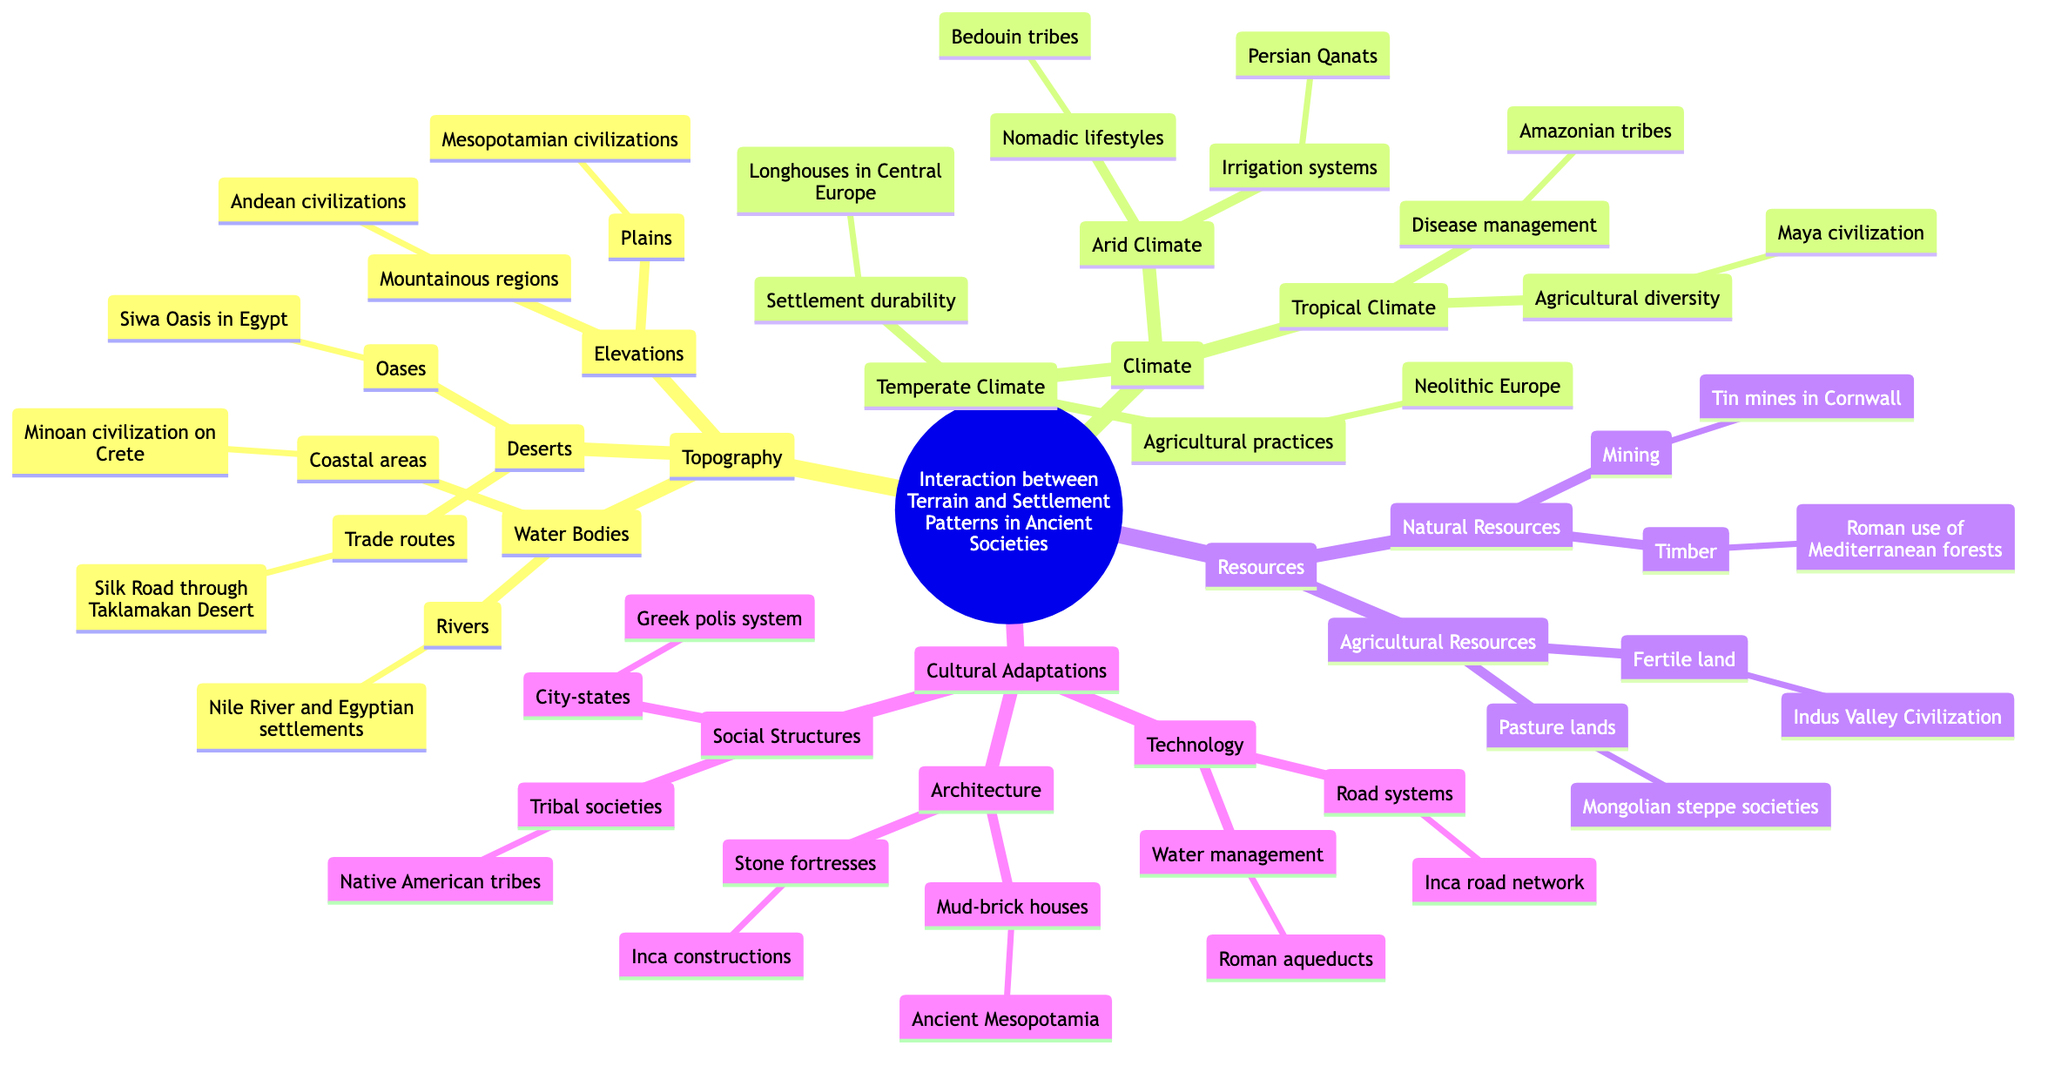What are the three main sub-topics under the main topic? The main topic branches into four sub-topics: Topography, Climate, Resources, and Cultural Adaptations.
Answer: Topography, Climate, Resources, Cultural Adaptations How many types of climate are represented in the diagram? The diagram lists three types of climate: Temperate Climate, Arid Climate, and Tropical Climate.
Answer: Three Which civilization is associated with the Nile River? Under the 'Water Bodies' section, the Nile River is connected to Egyptian settlements as an example.
Answer: Egyptian settlements What natural resource is linked to Cornwall? The 'Natural Resources' branch mentions mining, specifically referring to tin mines in Cornwall.
Answer: Tin mines How do the Andean civilizations adapt to mountainous regions? It suggests adaptations unique to elevations, with specific examples noted under mountainous regions associated with the Andean civilizations.
Answer: Mountainous regions What social structure example is given under Cultural Adaptations? The 'Social Structures' branch includes the Greek polis system as an example of city-states.
Answer: Greek polis system Which agricultural practice is highlighted in temperate climates? The diagram notes agricultural practices in Neolithic Europe under the Temperate Climate section.
Answer: Neolithic Europe How do Bedouin tribes adapt to Arid Climate? The diagram states that Bedouin tribes are an example of nomadic lifestyles under the Arid Climate section.
Answer: Nomadic lifestyles What is the example of an irrigation system provided in the diagram? The example provided under Arid Climate is Persian Qanats as a type of irrigation system.
Answer: Persian Qanats 